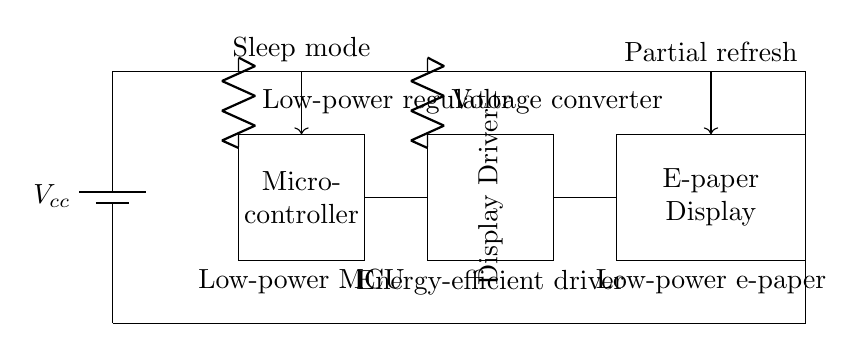What is the power supply in the circuit? The power supply in the circuit is represented by the battery component labeled Vcc, which provides the necessary voltage for the entire circuit to operate.
Answer: Vcc What types of components are used for energy efficiency in the circuit? The circuit includes a low-power regulator and a voltage converter, both labeled as low-power components, which are critical for reducing energy consumption while maintaining performance.
Answer: Low-power regulator and Voltage converter How is the sleep mode activated in this circuit? The circuit shows an arrow pointing from the microcontroller labeled "Sleep mode," indicating that it can enter a low-power state when not in active use, which helps save energy.
Answer: Through the microcontroller What connects the microcontroller to the display driver? A direct line or wire connection from the microcontroller to the display driver is depicted, which shows the data signals being transmitted between the two components.
Answer: Wire connection What is the purpose of the partial refresh feature in the circuit? The partial refresh feature, indicated by an arrow from the display to the top labeled "Partial refresh," allows the e-paper display to update only a portion of its contents without redraws, saving power by reducing active screen areas.
Answer: To save power Which type of display is represented in the circuit? The diagram showcases an e-paper display, characterized by its low-power consumption and the unique requirements for driving that type of technology effectively.
Answer: E-paper display 